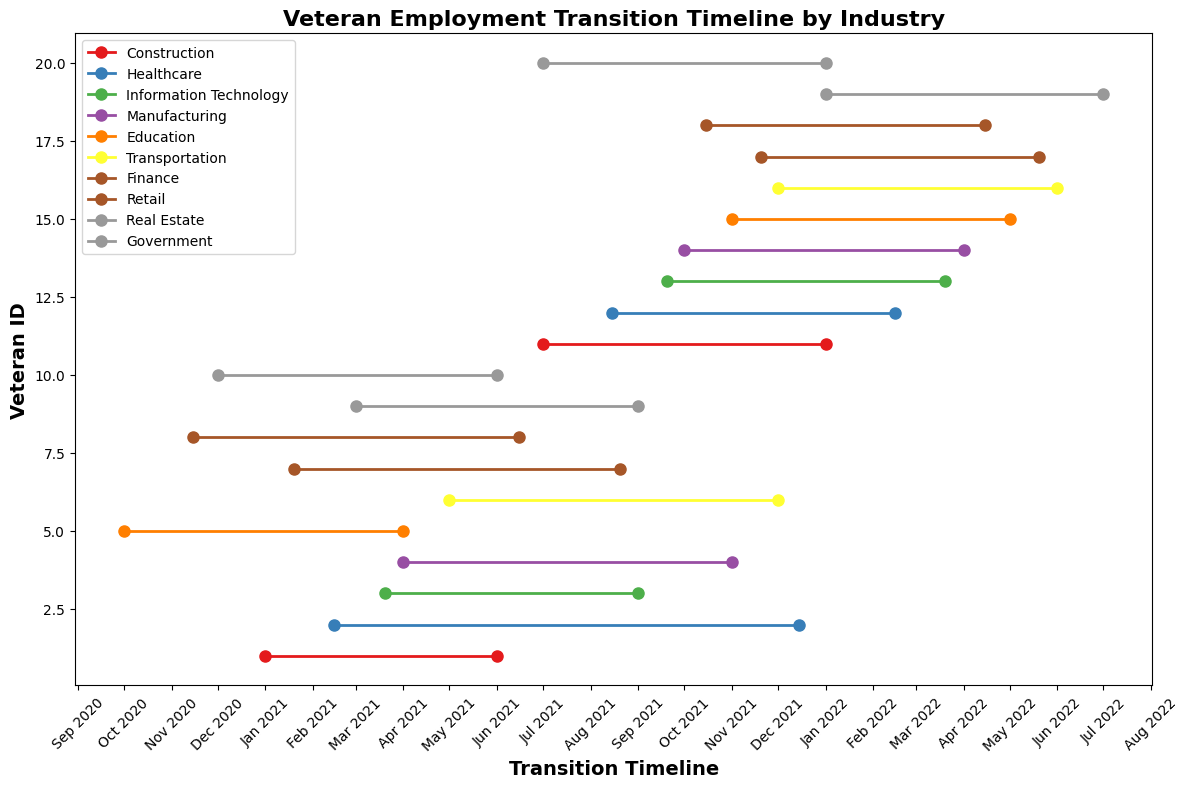Which industry has the largest number of veterans transitioning? To determine this, we need to look at how many veterans are transitioning in each industry, which is visualized by the sets of lines corresponding to each industry. By counting the lines, we can see that Healthcare and Construction both have more transitions compared to other industries.
Answer: Healthcare and Construction Which veteran had the shortest transition period? The transition period can be visually determined by looking at the length of the lines on the plot. The shorter the line, the shorter the transition period. By comparing, we see that Veteran 1 in Construction has the shortest line.
Answer: Veteran 1 What is the average transition duration for the Retail industry? First, calculate the duration of transitions for each veteran in Retail. Veteran 8's duration is from Nov 15, 2020 to Jun 15, 2021 (7 months), and Veteran 18’s duration is from Oct 15, 2021 to Apr 15, 2022 (6 months). Then, average these durations: (7 + 6) / 2 = 6.5 months.
Answer: 6.5 months Which industry had veterans transitioning in the most recent period? To identify this, look for the industry with lines extending furthest to the right (most recent dates). Real Estate has the latest transitions ending in Jul 2022.
Answer: Real Estate How does the transition duration for the Government industry in 2021 compare to that in 2022? For 2021, Veteran 10's transition in Government was from Dec 2020 to Jun 2021 (6 months). For 2022, Veteran 20's transition was from Jul 2021 to Jan 2022 (6 months). So both transitions were 6 months long.
Answer: Equal Which industry had the longest continuous transition period? For the longest continuous transition period within any single veteran's timeline, determine by viewing the lengthiest single line. Veteran 12 in Healthcare had a transition from Aug 2021 to Feb 2022 (6 months), and several others also have similar or slightly longer stretches, but notably, IT in Veteran 13’s timeline shows a continuous line from Sep 2021 to Mar 2022 (6 months).
Answer: Information Technology What is the total number of veterans transitioning in the Education industry? Count the distinct lines corresponding to the Education industry. Veterans 5 and 15 are transitioning in Education.
Answer: 2 Which transition ended earliest in the timeline? The earliest transition end date is identified by finding the leftmost endpoint of the lines. Veteran 5 in Education ended their transition on April 1, 2021.
Answer: Education How many months did Veterans 9 and 19 from Real Estate spend in their transitions? Veteran 9’s transition duration was from Mar 2021 to Sep 2021 (6 months). Veteran 19’s transition duration was from Jan 2022 to Jul 2022 (6 months). So combined, (6 + 6) = 12 months.
Answer: 12 months 